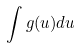Convert formula to latex. <formula><loc_0><loc_0><loc_500><loc_500>\int g ( u ) d u</formula> 